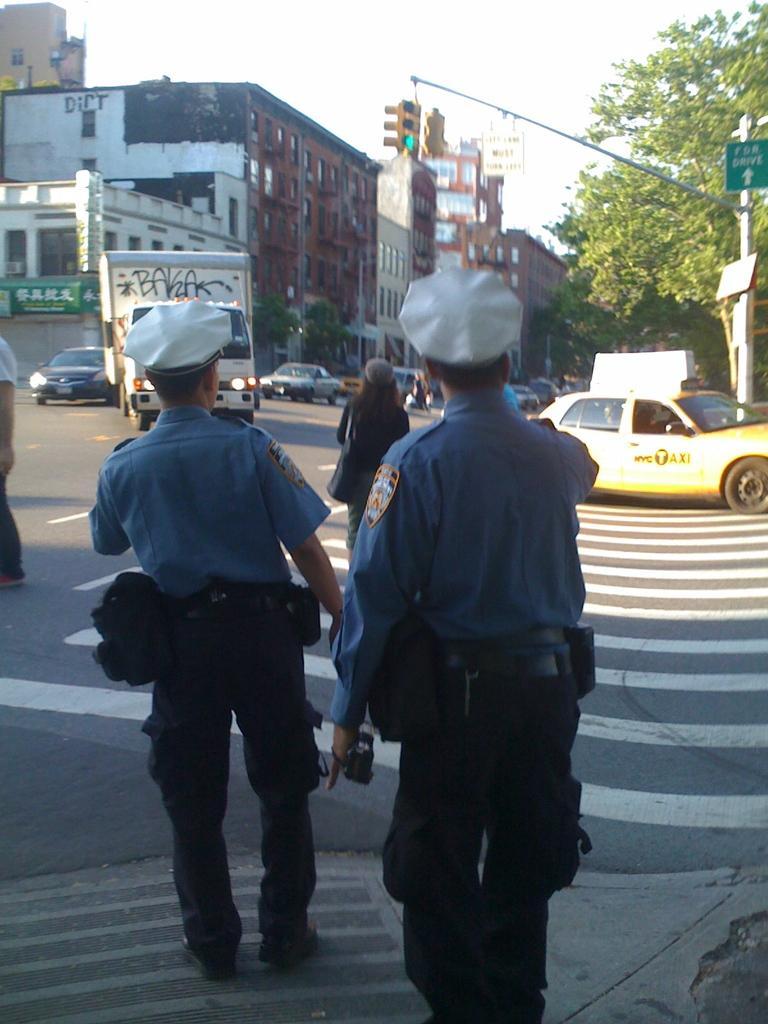Describe this image in one or two sentences. In this image, there are a few people, buildings, trees, vehicles and boards. We can see the ground and the sky. We can also see a pole. 